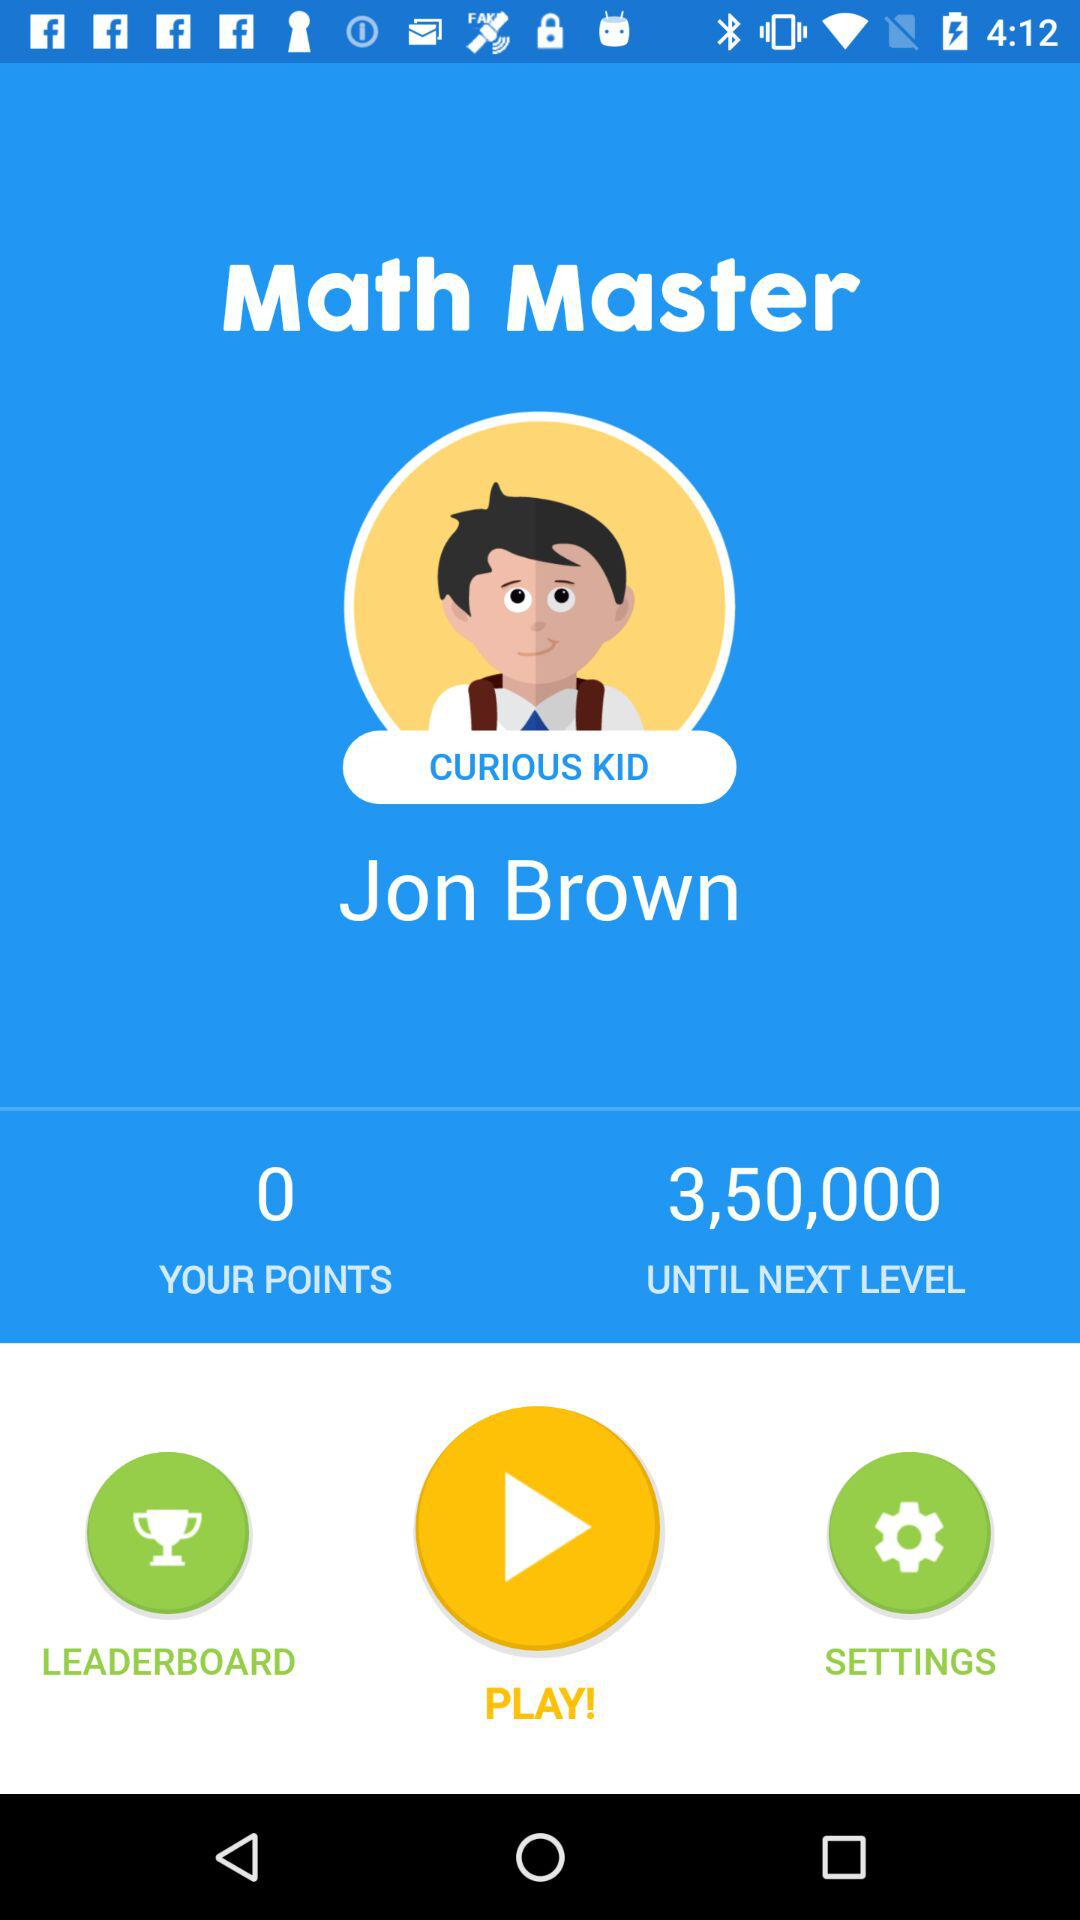What is the name of the application? The name of the application is "Math Master". 